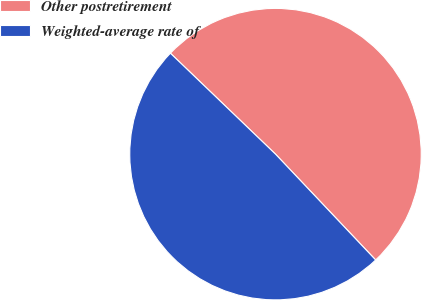<chart> <loc_0><loc_0><loc_500><loc_500><pie_chart><fcel>Other postretirement<fcel>Weighted-average rate of<nl><fcel>50.76%<fcel>49.24%<nl></chart> 